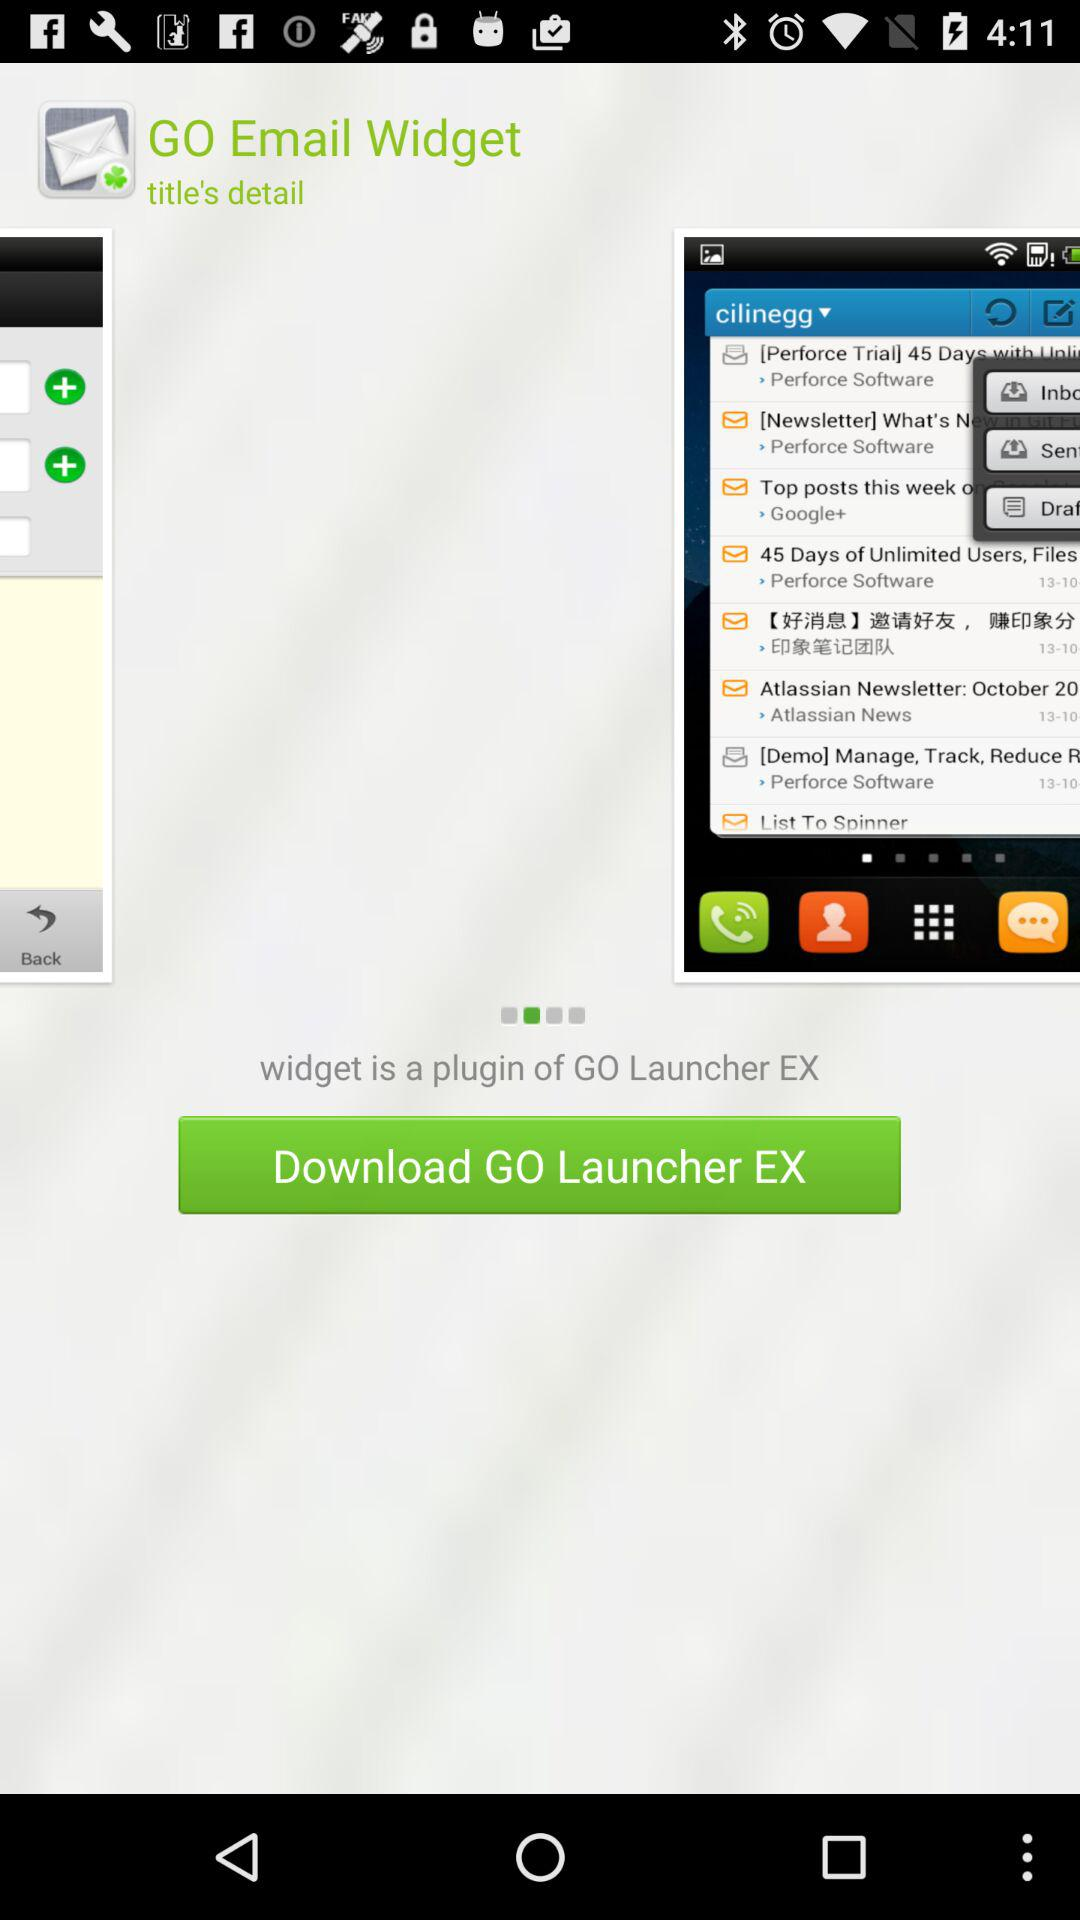How much is the application?
When the provided information is insufficient, respond with <no answer>. <no answer> 